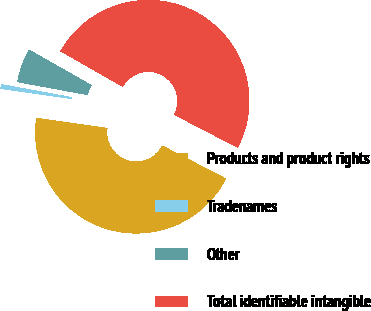Convert chart. <chart><loc_0><loc_0><loc_500><loc_500><pie_chart><fcel>Products and product rights<fcel>Tradenames<fcel>Other<fcel>Total identifiable intangible<nl><fcel>44.64%<fcel>0.64%<fcel>5.36%<fcel>49.36%<nl></chart> 